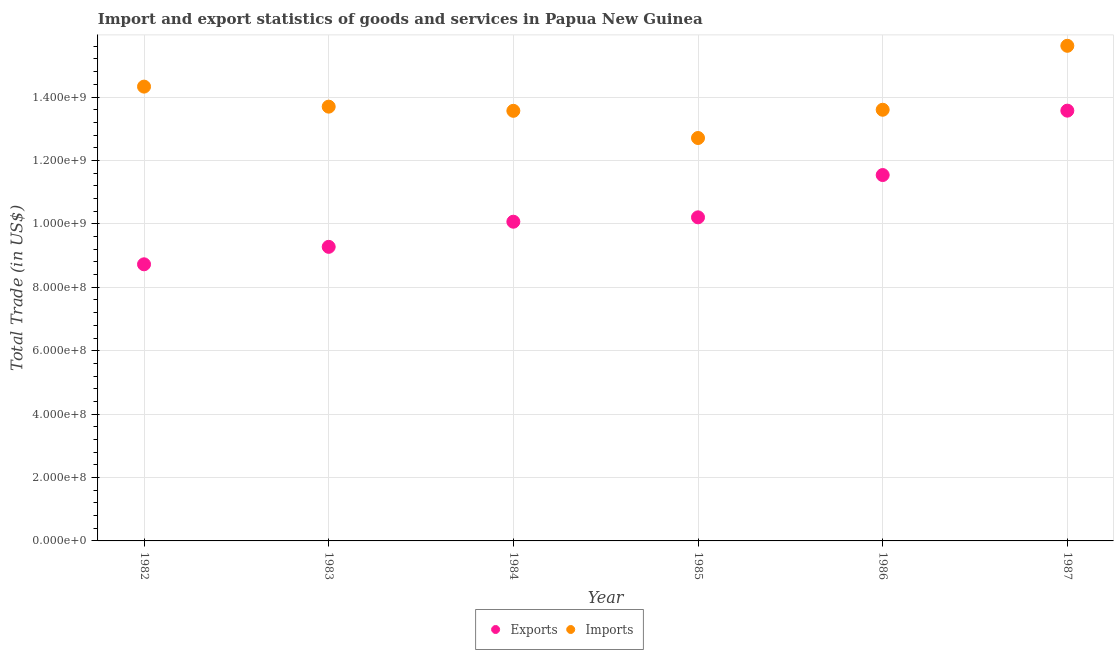What is the export of goods and services in 1984?
Provide a succinct answer. 1.01e+09. Across all years, what is the maximum export of goods and services?
Give a very brief answer. 1.36e+09. Across all years, what is the minimum imports of goods and services?
Your answer should be very brief. 1.27e+09. In which year was the imports of goods and services maximum?
Keep it short and to the point. 1987. What is the total imports of goods and services in the graph?
Your answer should be compact. 8.35e+09. What is the difference between the imports of goods and services in 1983 and that in 1987?
Your answer should be very brief. -1.92e+08. What is the difference between the imports of goods and services in 1983 and the export of goods and services in 1984?
Your answer should be compact. 3.63e+08. What is the average imports of goods and services per year?
Give a very brief answer. 1.39e+09. In the year 1984, what is the difference between the export of goods and services and imports of goods and services?
Offer a very short reply. -3.50e+08. What is the ratio of the imports of goods and services in 1983 to that in 1985?
Ensure brevity in your answer.  1.08. What is the difference between the highest and the second highest export of goods and services?
Keep it short and to the point. 2.03e+08. What is the difference between the highest and the lowest export of goods and services?
Offer a terse response. 4.85e+08. Is the imports of goods and services strictly less than the export of goods and services over the years?
Your answer should be very brief. No. How many dotlines are there?
Your answer should be very brief. 2. How many years are there in the graph?
Offer a very short reply. 6. What is the difference between two consecutive major ticks on the Y-axis?
Offer a terse response. 2.00e+08. Are the values on the major ticks of Y-axis written in scientific E-notation?
Give a very brief answer. Yes. Does the graph contain any zero values?
Make the answer very short. No. Where does the legend appear in the graph?
Ensure brevity in your answer.  Bottom center. How many legend labels are there?
Give a very brief answer. 2. What is the title of the graph?
Provide a short and direct response. Import and export statistics of goods and services in Papua New Guinea. What is the label or title of the Y-axis?
Provide a succinct answer. Total Trade (in US$). What is the Total Trade (in US$) of Exports in 1982?
Give a very brief answer. 8.72e+08. What is the Total Trade (in US$) in Imports in 1982?
Provide a succinct answer. 1.43e+09. What is the Total Trade (in US$) of Exports in 1983?
Make the answer very short. 9.28e+08. What is the Total Trade (in US$) of Imports in 1983?
Your answer should be very brief. 1.37e+09. What is the Total Trade (in US$) of Exports in 1984?
Make the answer very short. 1.01e+09. What is the Total Trade (in US$) of Imports in 1984?
Give a very brief answer. 1.36e+09. What is the Total Trade (in US$) of Exports in 1985?
Provide a succinct answer. 1.02e+09. What is the Total Trade (in US$) in Imports in 1985?
Give a very brief answer. 1.27e+09. What is the Total Trade (in US$) of Exports in 1986?
Your response must be concise. 1.15e+09. What is the Total Trade (in US$) in Imports in 1986?
Your response must be concise. 1.36e+09. What is the Total Trade (in US$) of Exports in 1987?
Give a very brief answer. 1.36e+09. What is the Total Trade (in US$) in Imports in 1987?
Provide a succinct answer. 1.56e+09. Across all years, what is the maximum Total Trade (in US$) in Exports?
Provide a short and direct response. 1.36e+09. Across all years, what is the maximum Total Trade (in US$) of Imports?
Your answer should be compact. 1.56e+09. Across all years, what is the minimum Total Trade (in US$) of Exports?
Your response must be concise. 8.72e+08. Across all years, what is the minimum Total Trade (in US$) of Imports?
Keep it short and to the point. 1.27e+09. What is the total Total Trade (in US$) of Exports in the graph?
Provide a succinct answer. 6.34e+09. What is the total Total Trade (in US$) of Imports in the graph?
Keep it short and to the point. 8.35e+09. What is the difference between the Total Trade (in US$) of Exports in 1982 and that in 1983?
Your response must be concise. -5.51e+07. What is the difference between the Total Trade (in US$) of Imports in 1982 and that in 1983?
Offer a very short reply. 6.32e+07. What is the difference between the Total Trade (in US$) of Exports in 1982 and that in 1984?
Your answer should be compact. -1.34e+08. What is the difference between the Total Trade (in US$) of Imports in 1982 and that in 1984?
Keep it short and to the point. 7.63e+07. What is the difference between the Total Trade (in US$) of Exports in 1982 and that in 1985?
Your answer should be compact. -1.48e+08. What is the difference between the Total Trade (in US$) in Imports in 1982 and that in 1985?
Your response must be concise. 1.62e+08. What is the difference between the Total Trade (in US$) in Exports in 1982 and that in 1986?
Your answer should be very brief. -2.82e+08. What is the difference between the Total Trade (in US$) in Imports in 1982 and that in 1986?
Offer a terse response. 7.30e+07. What is the difference between the Total Trade (in US$) of Exports in 1982 and that in 1987?
Your response must be concise. -4.85e+08. What is the difference between the Total Trade (in US$) in Imports in 1982 and that in 1987?
Offer a terse response. -1.29e+08. What is the difference between the Total Trade (in US$) in Exports in 1983 and that in 1984?
Keep it short and to the point. -7.93e+07. What is the difference between the Total Trade (in US$) of Imports in 1983 and that in 1984?
Your response must be concise. 1.31e+07. What is the difference between the Total Trade (in US$) in Exports in 1983 and that in 1985?
Your answer should be very brief. -9.31e+07. What is the difference between the Total Trade (in US$) in Imports in 1983 and that in 1985?
Your answer should be compact. 9.89e+07. What is the difference between the Total Trade (in US$) of Exports in 1983 and that in 1986?
Your response must be concise. -2.26e+08. What is the difference between the Total Trade (in US$) in Imports in 1983 and that in 1986?
Offer a terse response. 9.80e+06. What is the difference between the Total Trade (in US$) in Exports in 1983 and that in 1987?
Make the answer very short. -4.30e+08. What is the difference between the Total Trade (in US$) of Imports in 1983 and that in 1987?
Give a very brief answer. -1.92e+08. What is the difference between the Total Trade (in US$) of Exports in 1984 and that in 1985?
Offer a terse response. -1.38e+07. What is the difference between the Total Trade (in US$) of Imports in 1984 and that in 1985?
Your response must be concise. 8.57e+07. What is the difference between the Total Trade (in US$) in Exports in 1984 and that in 1986?
Provide a short and direct response. -1.47e+08. What is the difference between the Total Trade (in US$) of Imports in 1984 and that in 1986?
Offer a terse response. -3.34e+06. What is the difference between the Total Trade (in US$) of Exports in 1984 and that in 1987?
Keep it short and to the point. -3.50e+08. What is the difference between the Total Trade (in US$) in Imports in 1984 and that in 1987?
Offer a very short reply. -2.05e+08. What is the difference between the Total Trade (in US$) in Exports in 1985 and that in 1986?
Offer a terse response. -1.33e+08. What is the difference between the Total Trade (in US$) in Imports in 1985 and that in 1986?
Give a very brief answer. -8.91e+07. What is the difference between the Total Trade (in US$) in Exports in 1985 and that in 1987?
Give a very brief answer. -3.36e+08. What is the difference between the Total Trade (in US$) of Imports in 1985 and that in 1987?
Your answer should be compact. -2.91e+08. What is the difference between the Total Trade (in US$) of Exports in 1986 and that in 1987?
Make the answer very short. -2.03e+08. What is the difference between the Total Trade (in US$) in Imports in 1986 and that in 1987?
Your answer should be very brief. -2.02e+08. What is the difference between the Total Trade (in US$) of Exports in 1982 and the Total Trade (in US$) of Imports in 1983?
Your response must be concise. -4.97e+08. What is the difference between the Total Trade (in US$) of Exports in 1982 and the Total Trade (in US$) of Imports in 1984?
Offer a very short reply. -4.84e+08. What is the difference between the Total Trade (in US$) of Exports in 1982 and the Total Trade (in US$) of Imports in 1985?
Offer a terse response. -3.98e+08. What is the difference between the Total Trade (in US$) in Exports in 1982 and the Total Trade (in US$) in Imports in 1986?
Provide a short and direct response. -4.87e+08. What is the difference between the Total Trade (in US$) in Exports in 1982 and the Total Trade (in US$) in Imports in 1987?
Provide a succinct answer. -6.89e+08. What is the difference between the Total Trade (in US$) of Exports in 1983 and the Total Trade (in US$) of Imports in 1984?
Ensure brevity in your answer.  -4.29e+08. What is the difference between the Total Trade (in US$) of Exports in 1983 and the Total Trade (in US$) of Imports in 1985?
Ensure brevity in your answer.  -3.43e+08. What is the difference between the Total Trade (in US$) in Exports in 1983 and the Total Trade (in US$) in Imports in 1986?
Make the answer very short. -4.32e+08. What is the difference between the Total Trade (in US$) of Exports in 1983 and the Total Trade (in US$) of Imports in 1987?
Your response must be concise. -6.34e+08. What is the difference between the Total Trade (in US$) in Exports in 1984 and the Total Trade (in US$) in Imports in 1985?
Your answer should be compact. -2.64e+08. What is the difference between the Total Trade (in US$) in Exports in 1984 and the Total Trade (in US$) in Imports in 1986?
Provide a succinct answer. -3.53e+08. What is the difference between the Total Trade (in US$) of Exports in 1984 and the Total Trade (in US$) of Imports in 1987?
Your answer should be very brief. -5.55e+08. What is the difference between the Total Trade (in US$) in Exports in 1985 and the Total Trade (in US$) in Imports in 1986?
Your answer should be very brief. -3.39e+08. What is the difference between the Total Trade (in US$) of Exports in 1985 and the Total Trade (in US$) of Imports in 1987?
Make the answer very short. -5.41e+08. What is the difference between the Total Trade (in US$) in Exports in 1986 and the Total Trade (in US$) in Imports in 1987?
Give a very brief answer. -4.08e+08. What is the average Total Trade (in US$) in Exports per year?
Offer a very short reply. 1.06e+09. What is the average Total Trade (in US$) in Imports per year?
Keep it short and to the point. 1.39e+09. In the year 1982, what is the difference between the Total Trade (in US$) in Exports and Total Trade (in US$) in Imports?
Your answer should be very brief. -5.60e+08. In the year 1983, what is the difference between the Total Trade (in US$) of Exports and Total Trade (in US$) of Imports?
Your answer should be very brief. -4.42e+08. In the year 1984, what is the difference between the Total Trade (in US$) of Exports and Total Trade (in US$) of Imports?
Offer a very short reply. -3.50e+08. In the year 1985, what is the difference between the Total Trade (in US$) of Exports and Total Trade (in US$) of Imports?
Your answer should be very brief. -2.50e+08. In the year 1986, what is the difference between the Total Trade (in US$) in Exports and Total Trade (in US$) in Imports?
Your answer should be compact. -2.06e+08. In the year 1987, what is the difference between the Total Trade (in US$) of Exports and Total Trade (in US$) of Imports?
Provide a succinct answer. -2.05e+08. What is the ratio of the Total Trade (in US$) in Exports in 1982 to that in 1983?
Provide a succinct answer. 0.94. What is the ratio of the Total Trade (in US$) in Imports in 1982 to that in 1983?
Offer a very short reply. 1.05. What is the ratio of the Total Trade (in US$) of Exports in 1982 to that in 1984?
Offer a terse response. 0.87. What is the ratio of the Total Trade (in US$) in Imports in 1982 to that in 1984?
Give a very brief answer. 1.06. What is the ratio of the Total Trade (in US$) of Exports in 1982 to that in 1985?
Give a very brief answer. 0.85. What is the ratio of the Total Trade (in US$) in Imports in 1982 to that in 1985?
Make the answer very short. 1.13. What is the ratio of the Total Trade (in US$) of Exports in 1982 to that in 1986?
Your answer should be very brief. 0.76. What is the ratio of the Total Trade (in US$) in Imports in 1982 to that in 1986?
Provide a short and direct response. 1.05. What is the ratio of the Total Trade (in US$) of Exports in 1982 to that in 1987?
Your answer should be compact. 0.64. What is the ratio of the Total Trade (in US$) of Imports in 1982 to that in 1987?
Make the answer very short. 0.92. What is the ratio of the Total Trade (in US$) in Exports in 1983 to that in 1984?
Provide a short and direct response. 0.92. What is the ratio of the Total Trade (in US$) in Imports in 1983 to that in 1984?
Ensure brevity in your answer.  1.01. What is the ratio of the Total Trade (in US$) of Exports in 1983 to that in 1985?
Provide a short and direct response. 0.91. What is the ratio of the Total Trade (in US$) of Imports in 1983 to that in 1985?
Give a very brief answer. 1.08. What is the ratio of the Total Trade (in US$) of Exports in 1983 to that in 1986?
Ensure brevity in your answer.  0.8. What is the ratio of the Total Trade (in US$) in Imports in 1983 to that in 1986?
Give a very brief answer. 1.01. What is the ratio of the Total Trade (in US$) in Exports in 1983 to that in 1987?
Your answer should be compact. 0.68. What is the ratio of the Total Trade (in US$) in Imports in 1983 to that in 1987?
Ensure brevity in your answer.  0.88. What is the ratio of the Total Trade (in US$) of Exports in 1984 to that in 1985?
Keep it short and to the point. 0.99. What is the ratio of the Total Trade (in US$) of Imports in 1984 to that in 1985?
Make the answer very short. 1.07. What is the ratio of the Total Trade (in US$) of Exports in 1984 to that in 1986?
Provide a short and direct response. 0.87. What is the ratio of the Total Trade (in US$) of Imports in 1984 to that in 1986?
Your answer should be compact. 1. What is the ratio of the Total Trade (in US$) in Exports in 1984 to that in 1987?
Make the answer very short. 0.74. What is the ratio of the Total Trade (in US$) of Imports in 1984 to that in 1987?
Your response must be concise. 0.87. What is the ratio of the Total Trade (in US$) in Exports in 1985 to that in 1986?
Your answer should be very brief. 0.88. What is the ratio of the Total Trade (in US$) of Imports in 1985 to that in 1986?
Offer a very short reply. 0.93. What is the ratio of the Total Trade (in US$) in Exports in 1985 to that in 1987?
Offer a very short reply. 0.75. What is the ratio of the Total Trade (in US$) of Imports in 1985 to that in 1987?
Offer a terse response. 0.81. What is the ratio of the Total Trade (in US$) of Exports in 1986 to that in 1987?
Offer a very short reply. 0.85. What is the ratio of the Total Trade (in US$) of Imports in 1986 to that in 1987?
Your answer should be compact. 0.87. What is the difference between the highest and the second highest Total Trade (in US$) of Exports?
Offer a very short reply. 2.03e+08. What is the difference between the highest and the second highest Total Trade (in US$) in Imports?
Offer a terse response. 1.29e+08. What is the difference between the highest and the lowest Total Trade (in US$) in Exports?
Offer a very short reply. 4.85e+08. What is the difference between the highest and the lowest Total Trade (in US$) of Imports?
Give a very brief answer. 2.91e+08. 